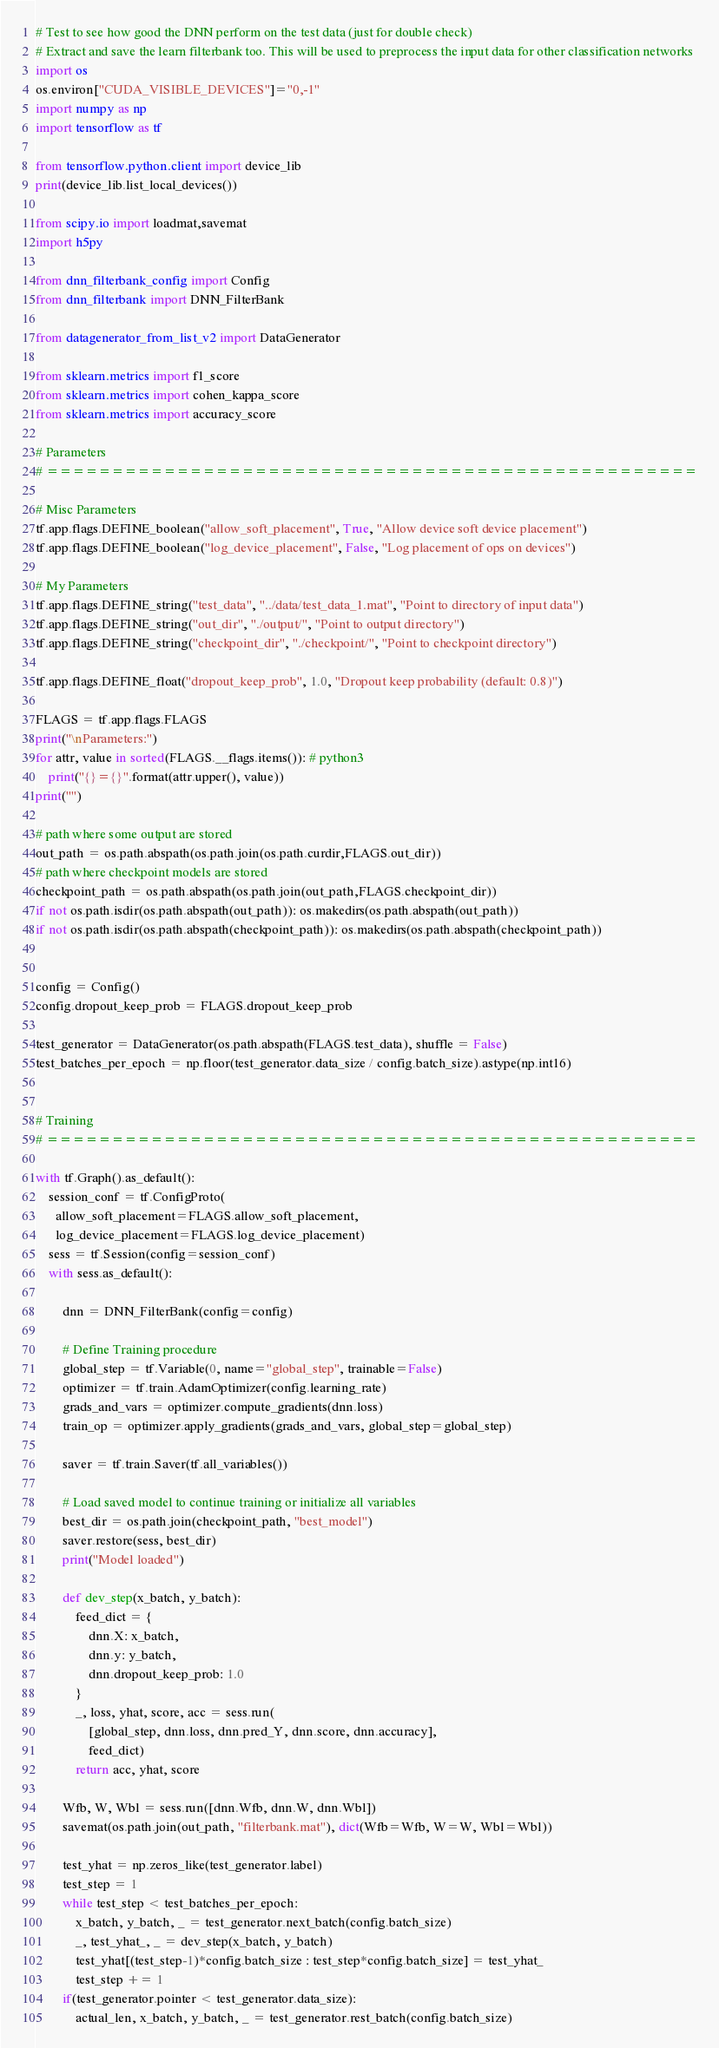Convert code to text. <code><loc_0><loc_0><loc_500><loc_500><_Python_># Test to see how good the DNN perform on the test data (just for double check)
# Extract and save the learn filterbank too. This will be used to preprocess the input data for other classification networks
import os
os.environ["CUDA_VISIBLE_DEVICES"]="0,-1"
import numpy as np
import tensorflow as tf

from tensorflow.python.client import device_lib
print(device_lib.list_local_devices())

from scipy.io import loadmat,savemat
import h5py

from dnn_filterbank_config import Config
from dnn_filterbank import DNN_FilterBank

from datagenerator_from_list_v2 import DataGenerator

from sklearn.metrics import f1_score
from sklearn.metrics import cohen_kappa_score
from sklearn.metrics import accuracy_score

# Parameters
# ==================================================

# Misc Parameters
tf.app.flags.DEFINE_boolean("allow_soft_placement", True, "Allow device soft device placement")
tf.app.flags.DEFINE_boolean("log_device_placement", False, "Log placement of ops on devices")

# My Parameters
tf.app.flags.DEFINE_string("test_data", "../data/test_data_1.mat", "Point to directory of input data")
tf.app.flags.DEFINE_string("out_dir", "./output/", "Point to output directory")
tf.app.flags.DEFINE_string("checkpoint_dir", "./checkpoint/", "Point to checkpoint directory")

tf.app.flags.DEFINE_float("dropout_keep_prob", 1.0, "Dropout keep probability (default: 0.8)")

FLAGS = tf.app.flags.FLAGS
print("\nParameters:")
for attr, value in sorted(FLAGS.__flags.items()): # python3
    print("{}={}".format(attr.upper(), value))
print("")

# path where some output are stored
out_path = os.path.abspath(os.path.join(os.path.curdir,FLAGS.out_dir))
# path where checkpoint models are stored
checkpoint_path = os.path.abspath(os.path.join(out_path,FLAGS.checkpoint_dir))
if not os.path.isdir(os.path.abspath(out_path)): os.makedirs(os.path.abspath(out_path))
if not os.path.isdir(os.path.abspath(checkpoint_path)): os.makedirs(os.path.abspath(checkpoint_path))


config = Config()
config.dropout_keep_prob = FLAGS.dropout_keep_prob

test_generator = DataGenerator(os.path.abspath(FLAGS.test_data), shuffle = False)
test_batches_per_epoch = np.floor(test_generator.data_size / config.batch_size).astype(np.int16)


# Training
# ==================================================

with tf.Graph().as_default():
    session_conf = tf.ConfigProto(
      allow_soft_placement=FLAGS.allow_soft_placement,
      log_device_placement=FLAGS.log_device_placement)
    sess = tf.Session(config=session_conf)
    with sess.as_default():

        dnn = DNN_FilterBank(config=config)

        # Define Training procedure
        global_step = tf.Variable(0, name="global_step", trainable=False)
        optimizer = tf.train.AdamOptimizer(config.learning_rate)
        grads_and_vars = optimizer.compute_gradients(dnn.loss)
        train_op = optimizer.apply_gradients(grads_and_vars, global_step=global_step)

        saver = tf.train.Saver(tf.all_variables())

        # Load saved model to continue training or initialize all variables
        best_dir = os.path.join(checkpoint_path, "best_model")
        saver.restore(sess, best_dir)
        print("Model loaded")

        def dev_step(x_batch, y_batch):
            feed_dict = {
                dnn.X: x_batch,
                dnn.y: y_batch,
                dnn.dropout_keep_prob: 1.0
            }
            _, loss, yhat, score, acc = sess.run(
                [global_step, dnn.loss, dnn.pred_Y, dnn.score, dnn.accuracy],
                feed_dict)
            return acc, yhat, score

        Wfb, W, Wbl = sess.run([dnn.Wfb, dnn.W, dnn.Wbl])
        savemat(os.path.join(out_path, "filterbank.mat"), dict(Wfb=Wfb, W=W, Wbl=Wbl))

        test_yhat = np.zeros_like(test_generator.label)
        test_step = 1
        while test_step < test_batches_per_epoch:
            x_batch, y_batch, _ = test_generator.next_batch(config.batch_size)
            _, test_yhat_, _ = dev_step(x_batch, y_batch)
            test_yhat[(test_step-1)*config.batch_size : test_step*config.batch_size] = test_yhat_
            test_step += 1
        if(test_generator.pointer < test_generator.data_size):
            actual_len, x_batch, y_batch, _ = test_generator.rest_batch(config.batch_size)</code> 